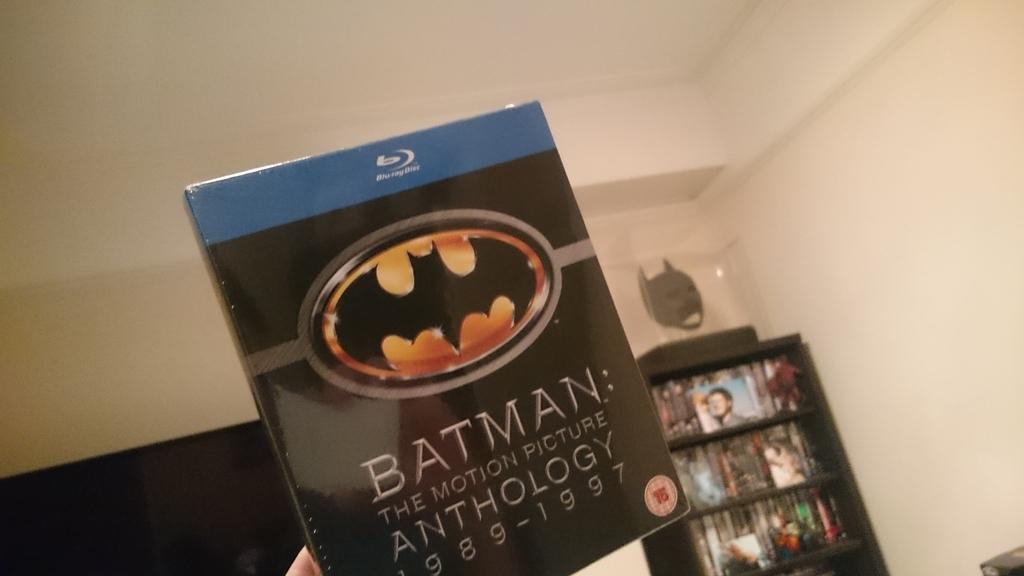Provide a one-sentence caption for the provided image. A hand is holding up a blu-ray copy of Batman:The Motion Picture Anthology 1989 -1997. 